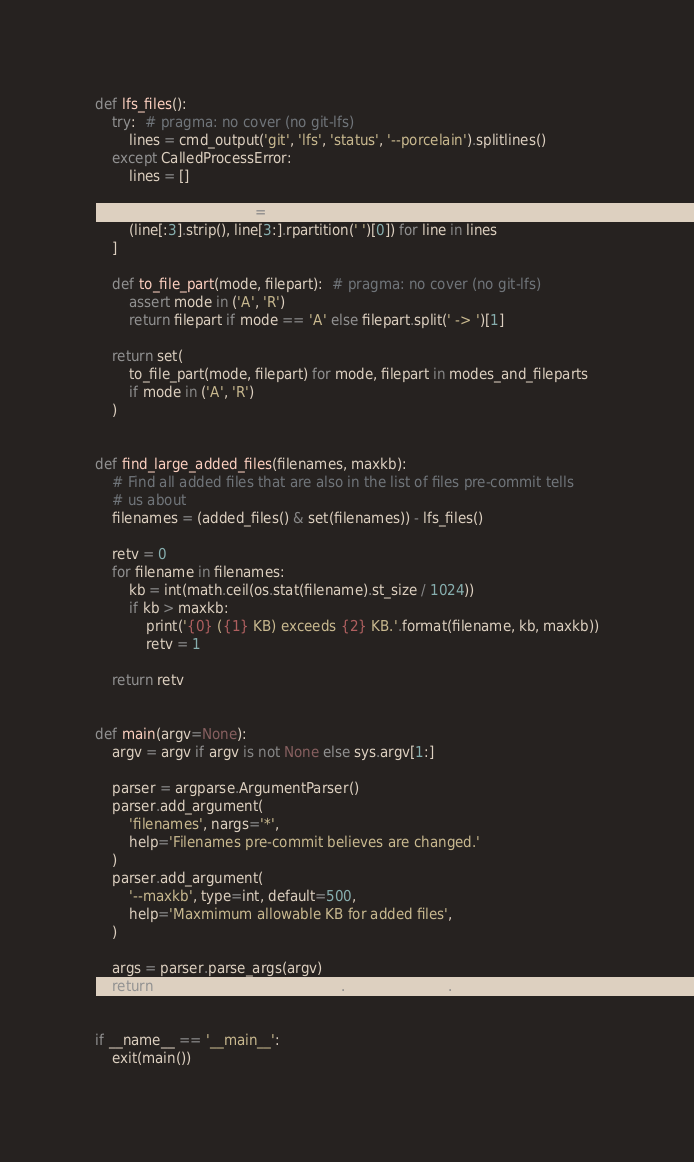Convert code to text. <code><loc_0><loc_0><loc_500><loc_500><_Python_>
def lfs_files():
    try:  # pragma: no cover (no git-lfs)
        lines = cmd_output('git', 'lfs', 'status', '--porcelain').splitlines()
    except CalledProcessError:
        lines = []

    modes_and_fileparts = [
        (line[:3].strip(), line[3:].rpartition(' ')[0]) for line in lines
    ]

    def to_file_part(mode, filepart):  # pragma: no cover (no git-lfs)
        assert mode in ('A', 'R')
        return filepart if mode == 'A' else filepart.split(' -> ')[1]

    return set(
        to_file_part(mode, filepart) for mode, filepart in modes_and_fileparts
        if mode in ('A', 'R')
    )


def find_large_added_files(filenames, maxkb):
    # Find all added files that are also in the list of files pre-commit tells
    # us about
    filenames = (added_files() & set(filenames)) - lfs_files()

    retv = 0
    for filename in filenames:
        kb = int(math.ceil(os.stat(filename).st_size / 1024))
        if kb > maxkb:
            print('{0} ({1} KB) exceeds {2} KB.'.format(filename, kb, maxkb))
            retv = 1

    return retv


def main(argv=None):
    argv = argv if argv is not None else sys.argv[1:]

    parser = argparse.ArgumentParser()
    parser.add_argument(
        'filenames', nargs='*',
        help='Filenames pre-commit believes are changed.'
    )
    parser.add_argument(
        '--maxkb', type=int, default=500,
        help='Maxmimum allowable KB for added files',
    )

    args = parser.parse_args(argv)
    return find_large_added_files(args.filenames, args.maxkb)


if __name__ == '__main__':
    exit(main())
</code> 